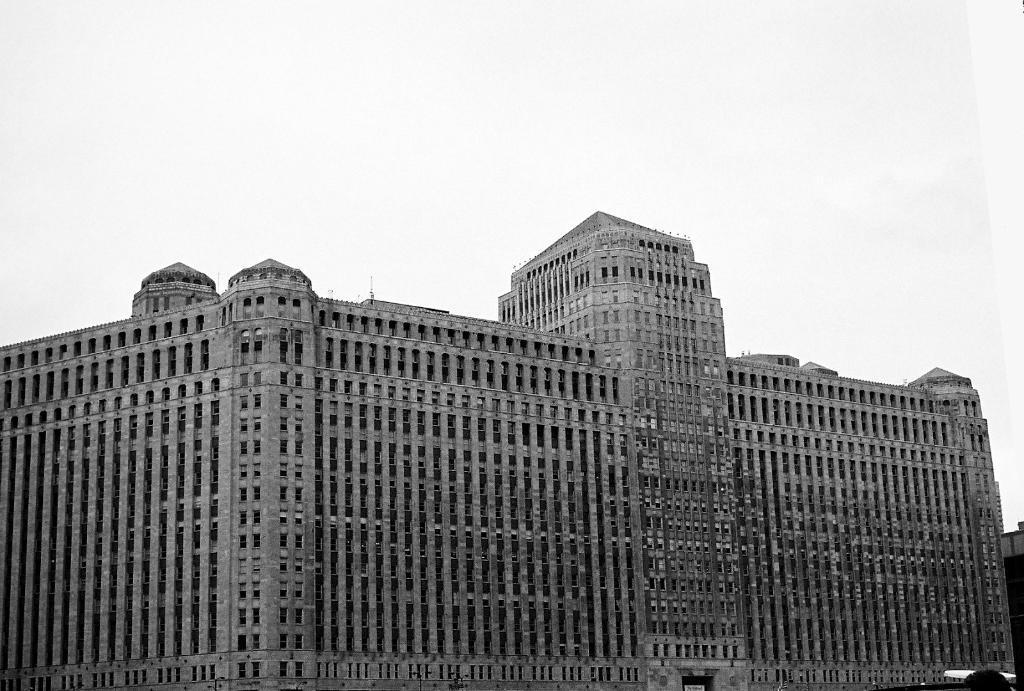Please provide a concise description of this image. This picture shows a building and we see a cloudy Sky. 